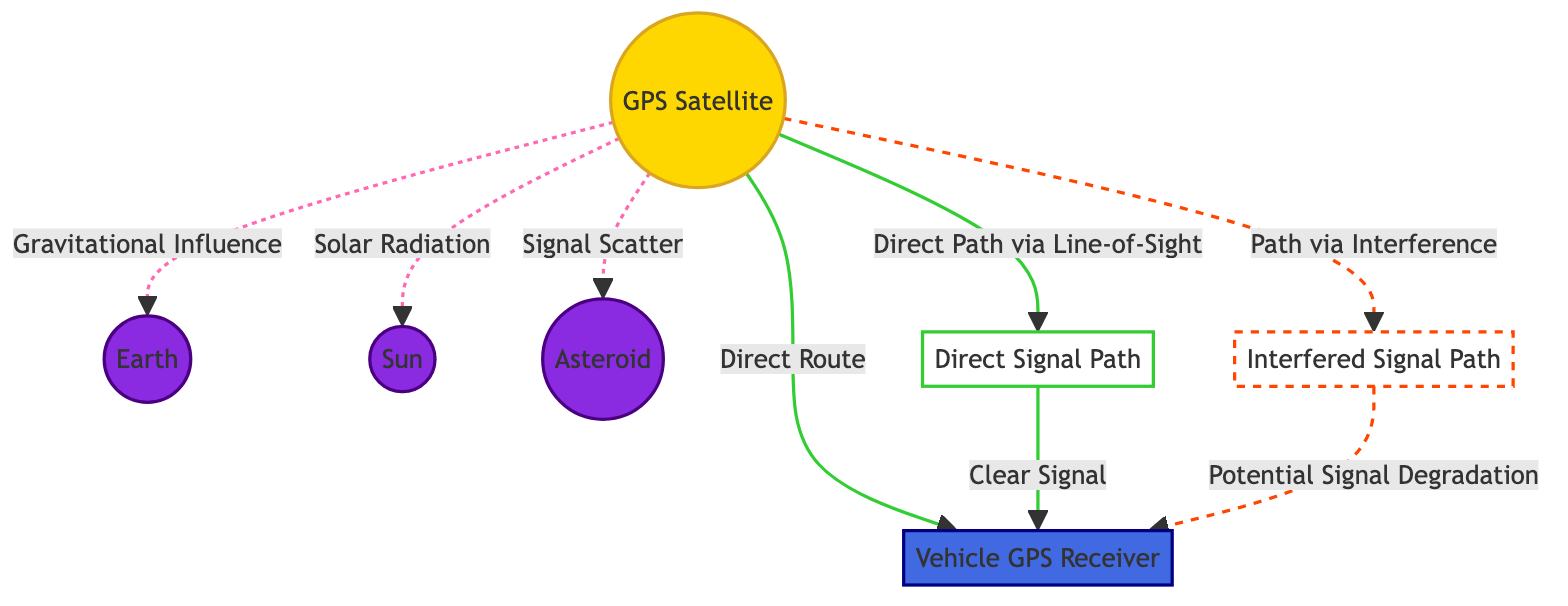What is the first node connecting to the vehicle GPS receiver? The first node connecting to the vehicle GPS receiver is the GPS Satellite, which is linked directly through a solid line indicating a direct route.
Answer: GPS Satellite How many sources of interference are identified in the diagram? There are three sources of interference identified in the diagram: gravitational influence from Earth, solar radiation from the Sun, and signal scatter from an asteroid.
Answer: 3 What is the relationship between the satellite and the sun? The relationship is that the satellite may experience solar radiation, which is indicated by a dashed line showing potential interference.
Answer: Solar Radiation Which path indicates potential signal degradation? The path indicating potential signal degradation is marked as the interfered route, which uses a dashed line to show that the signal may be affected by interference.
Answer: Interfered Signal Path What color represents the vehicle GPS receiver in the diagram? The vehicle GPS receiver is represented in blue, which corresponds to the class defined for vehicles in the diagram.
Answer: Blue What forms the direct signal path to the vehicle GPS receiver? The direct signal path is formed by the solid line linking the GPS Satellite directly to the vehicle GPS receiver without any interference.
Answer: Direct Route How does the GPS satellite interact with Earth? The GPS satellite interacts with Earth through gravitational influence, which is indicated by a dashed line in the diagram showing a potential interference path.
Answer: Gravitational Influence Which celestial body is shown as a potential source of signal scatter? The potential source of signal scatter is shown as an asteroid, which is connected to the GPS satellite with a dashed line indicating possible interference.
Answer: Asteroid What is used to differentiate between clear and interfered signal paths in the diagram? Clear signal paths are represented by solid lines, while interfered signal paths are shown with dashed lines, allowing for a clear differentiation between the two types of routes.
Answer: Solid and Dashed Lines 